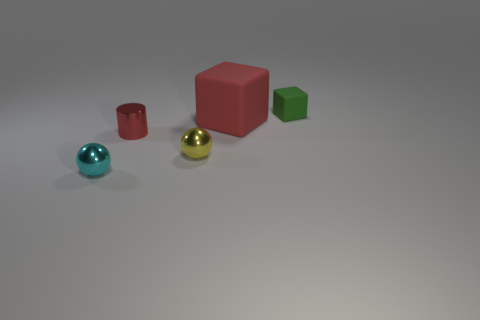Add 2 tiny objects. How many objects exist? 7 Subtract all balls. How many objects are left? 3 Add 3 small cylinders. How many small cylinders exist? 4 Subtract 0 brown cylinders. How many objects are left? 5 Subtract all tiny blue matte balls. Subtract all tiny cyan metal objects. How many objects are left? 4 Add 1 big red cubes. How many big red cubes are left? 2 